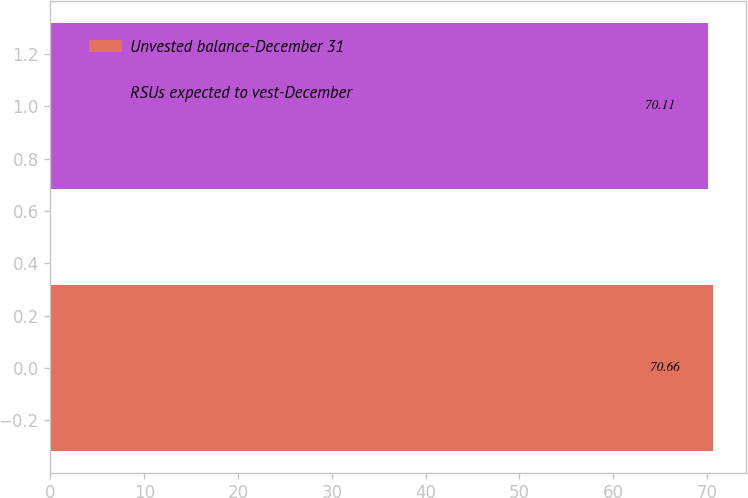<chart> <loc_0><loc_0><loc_500><loc_500><bar_chart><fcel>Unvested balance-December 31<fcel>RSUs expected to vest-December<nl><fcel>70.66<fcel>70.11<nl></chart> 